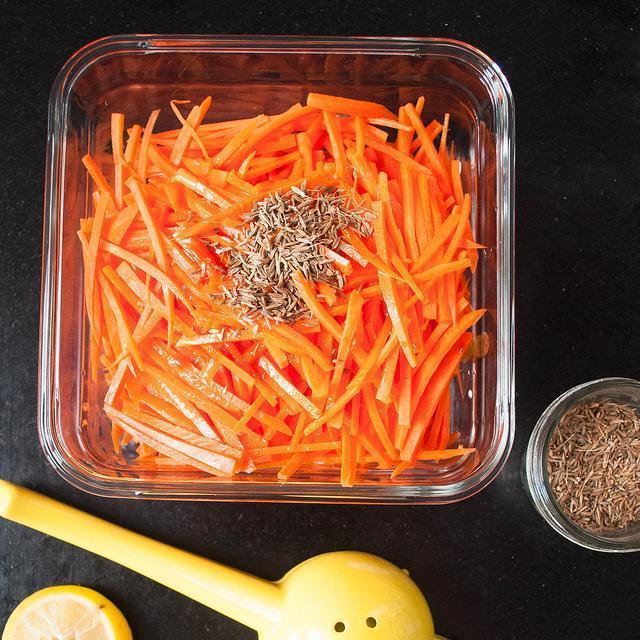How many lemons are in the picture?
Give a very brief answer. 1. How many bowls can you see?
Give a very brief answer. 2. How many dining tables are in the photo?
Give a very brief answer. 1. 